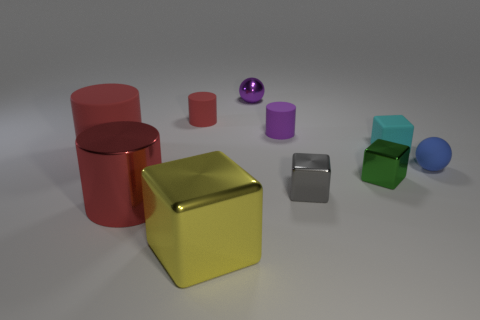Subtract all green spheres. How many red cylinders are left? 3 Subtract 1 cylinders. How many cylinders are left? 3 Subtract all green cylinders. Subtract all red balls. How many cylinders are left? 4 Subtract all blocks. How many objects are left? 6 Subtract 0 brown blocks. How many objects are left? 10 Subtract all small cyan rubber things. Subtract all rubber cylinders. How many objects are left? 6 Add 6 blue objects. How many blue objects are left? 7 Add 8 balls. How many balls exist? 10 